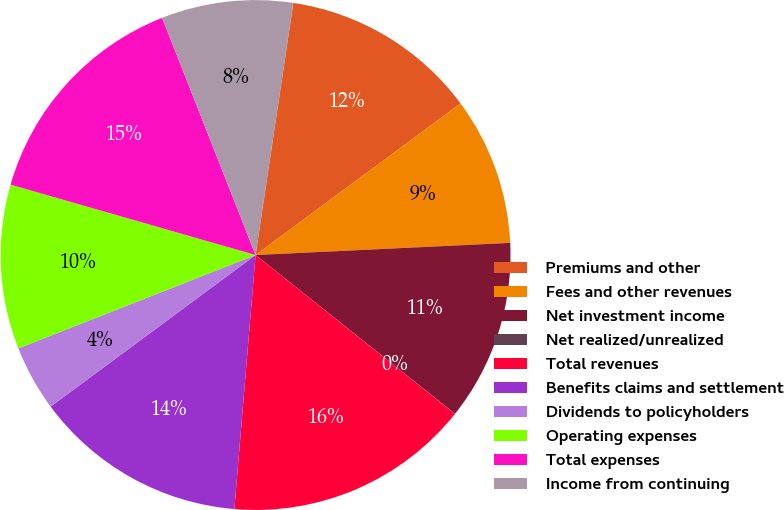Convert chart. <chart><loc_0><loc_0><loc_500><loc_500><pie_chart><fcel>Premiums and other<fcel>Fees and other revenues<fcel>Net investment income<fcel>Net realized/unrealized<fcel>Total revenues<fcel>Benefits claims and settlement<fcel>Dividends to policyholders<fcel>Operating expenses<fcel>Total expenses<fcel>Income from continuing<nl><fcel>12.5%<fcel>9.38%<fcel>11.46%<fcel>0.01%<fcel>15.62%<fcel>13.54%<fcel>4.17%<fcel>10.42%<fcel>14.58%<fcel>8.34%<nl></chart> 